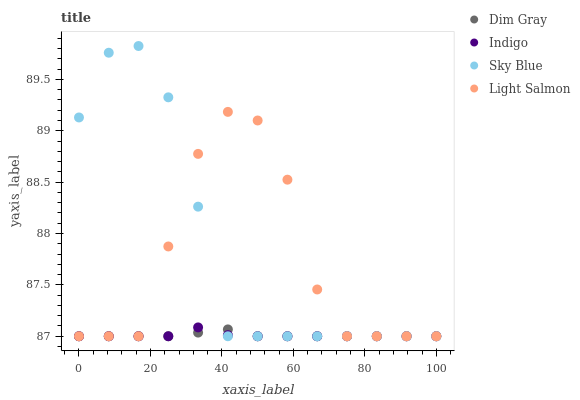Does Indigo have the minimum area under the curve?
Answer yes or no. Yes. Does Sky Blue have the maximum area under the curve?
Answer yes or no. Yes. Does Light Salmon have the minimum area under the curve?
Answer yes or no. No. Does Light Salmon have the maximum area under the curve?
Answer yes or no. No. Is Dim Gray the smoothest?
Answer yes or no. Yes. Is Light Salmon the roughest?
Answer yes or no. Yes. Is Light Salmon the smoothest?
Answer yes or no. No. Is Dim Gray the roughest?
Answer yes or no. No. Does Sky Blue have the lowest value?
Answer yes or no. Yes. Does Sky Blue have the highest value?
Answer yes or no. Yes. Does Light Salmon have the highest value?
Answer yes or no. No. Does Indigo intersect Sky Blue?
Answer yes or no. Yes. Is Indigo less than Sky Blue?
Answer yes or no. No. Is Indigo greater than Sky Blue?
Answer yes or no. No. 